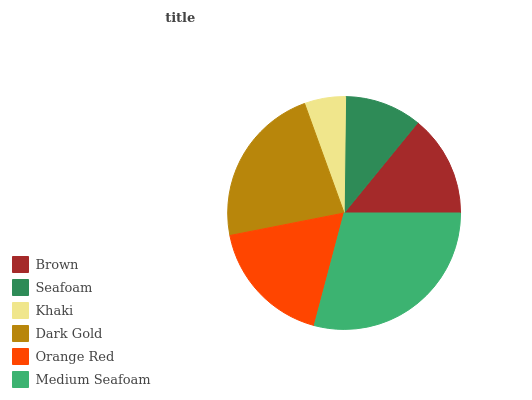Is Khaki the minimum?
Answer yes or no. Yes. Is Medium Seafoam the maximum?
Answer yes or no. Yes. Is Seafoam the minimum?
Answer yes or no. No. Is Seafoam the maximum?
Answer yes or no. No. Is Brown greater than Seafoam?
Answer yes or no. Yes. Is Seafoam less than Brown?
Answer yes or no. Yes. Is Seafoam greater than Brown?
Answer yes or no. No. Is Brown less than Seafoam?
Answer yes or no. No. Is Orange Red the high median?
Answer yes or no. Yes. Is Brown the low median?
Answer yes or no. Yes. Is Seafoam the high median?
Answer yes or no. No. Is Medium Seafoam the low median?
Answer yes or no. No. 